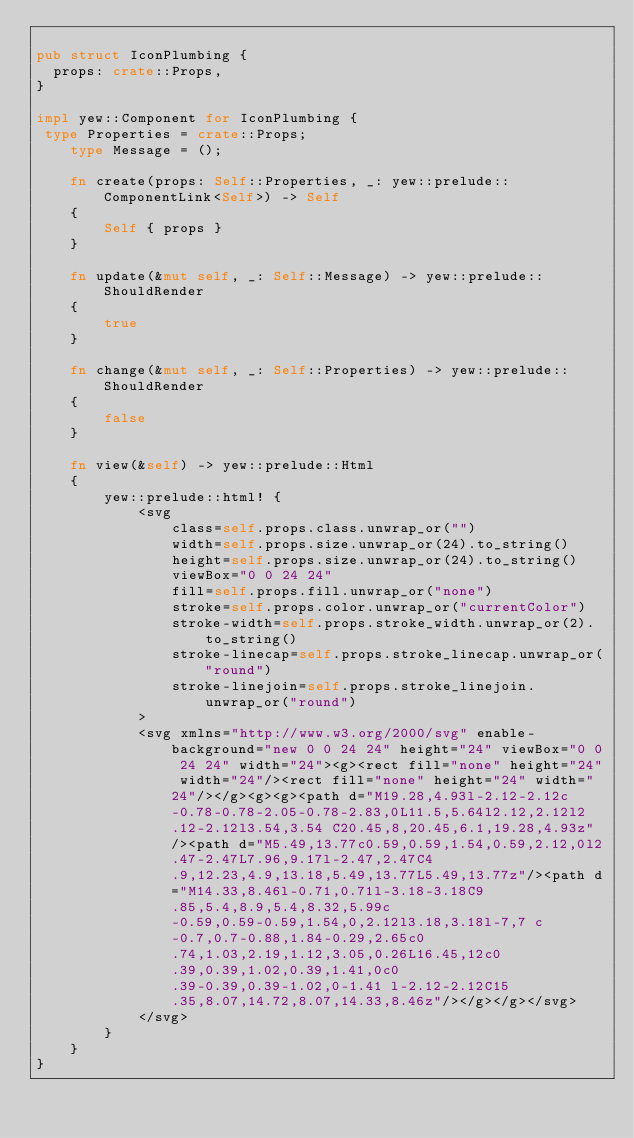Convert code to text. <code><loc_0><loc_0><loc_500><loc_500><_Rust_>
pub struct IconPlumbing {
  props: crate::Props,
}

impl yew::Component for IconPlumbing {
 type Properties = crate::Props;
    type Message = ();

    fn create(props: Self::Properties, _: yew::prelude::ComponentLink<Self>) -> Self
    {
        Self { props }
    }

    fn update(&mut self, _: Self::Message) -> yew::prelude::ShouldRender
    {
        true
    }

    fn change(&mut self, _: Self::Properties) -> yew::prelude::ShouldRender
    {
        false
    }

    fn view(&self) -> yew::prelude::Html
    {
        yew::prelude::html! {
            <svg
                class=self.props.class.unwrap_or("")
                width=self.props.size.unwrap_or(24).to_string()
                height=self.props.size.unwrap_or(24).to_string()
                viewBox="0 0 24 24"
                fill=self.props.fill.unwrap_or("none")
                stroke=self.props.color.unwrap_or("currentColor")
                stroke-width=self.props.stroke_width.unwrap_or(2).to_string()
                stroke-linecap=self.props.stroke_linecap.unwrap_or("round")
                stroke-linejoin=self.props.stroke_linejoin.unwrap_or("round")
            >
            <svg xmlns="http://www.w3.org/2000/svg" enable-background="new 0 0 24 24" height="24" viewBox="0 0 24 24" width="24"><g><rect fill="none" height="24" width="24"/><rect fill="none" height="24" width="24"/></g><g><g><path d="M19.28,4.93l-2.12-2.12c-0.78-0.78-2.05-0.78-2.83,0L11.5,5.64l2.12,2.12l2.12-2.12l3.54,3.54 C20.45,8,20.45,6.1,19.28,4.93z"/><path d="M5.49,13.77c0.59,0.59,1.54,0.59,2.12,0l2.47-2.47L7.96,9.17l-2.47,2.47C4.9,12.23,4.9,13.18,5.49,13.77L5.49,13.77z"/><path d="M14.33,8.46l-0.71,0.71l-3.18-3.18C9.85,5.4,8.9,5.4,8.32,5.99c-0.59,0.59-0.59,1.54,0,2.12l3.18,3.18l-7,7 c-0.7,0.7-0.88,1.84-0.29,2.65c0.74,1.03,2.19,1.12,3.05,0.26L16.45,12c0.39,0.39,1.02,0.39,1.41,0c0.39-0.39,0.39-1.02,0-1.41 l-2.12-2.12C15.35,8.07,14.72,8.07,14.33,8.46z"/></g></g></svg>
            </svg>
        }
    }
}


</code> 